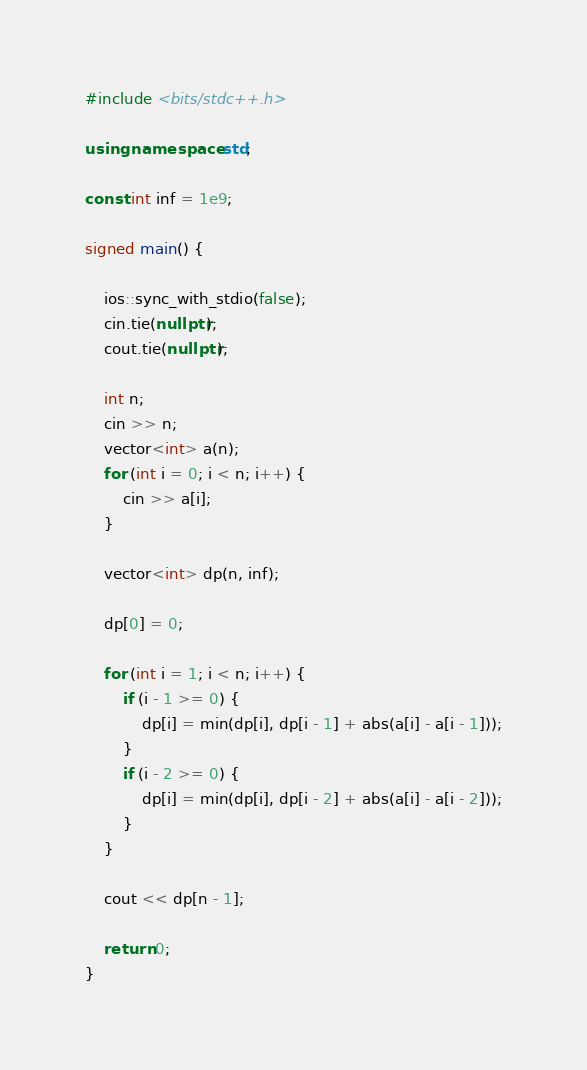Convert code to text. <code><loc_0><loc_0><loc_500><loc_500><_C++_>#include <bits/stdc++.h>

using namespace std;

const int inf = 1e9;

signed main() {
    
    ios::sync_with_stdio(false);
    cin.tie(nullptr);
    cout.tie(nullptr);
    
    int n;
    cin >> n;
    vector<int> a(n);
    for (int i = 0; i < n; i++) {
        cin >> a[i];
    }
    
    vector<int> dp(n, inf);
    
    dp[0] = 0;
    
    for (int i = 1; i < n; i++) {
        if (i - 1 >= 0) {
            dp[i] = min(dp[i], dp[i - 1] + abs(a[i] - a[i - 1]));
        }
        if (i - 2 >= 0) {
            dp[i] = min(dp[i], dp[i - 2] + abs(a[i] - a[i - 2]));
        }
    }
    
    cout << dp[n - 1];
    
    return 0;
}
</code> 